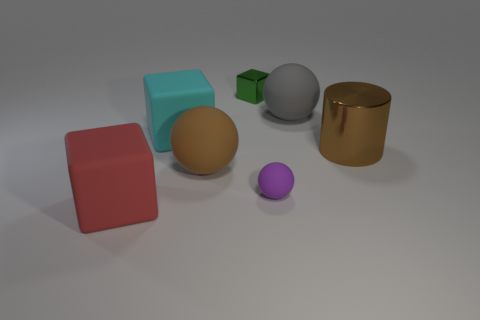Subtract all tiny rubber spheres. How many spheres are left? 2 Subtract all cyan cubes. How many cubes are left? 2 Subtract 1 blocks. How many blocks are left? 2 Add 2 cyan cubes. How many objects exist? 9 Subtract all blocks. How many objects are left? 4 Add 4 cyan rubber things. How many cyan rubber things are left? 5 Add 1 tiny purple shiny objects. How many tiny purple shiny objects exist? 1 Subtract 1 brown spheres. How many objects are left? 6 Subtract all green balls. Subtract all red cylinders. How many balls are left? 3 Subtract all purple cylinders. How many brown blocks are left? 0 